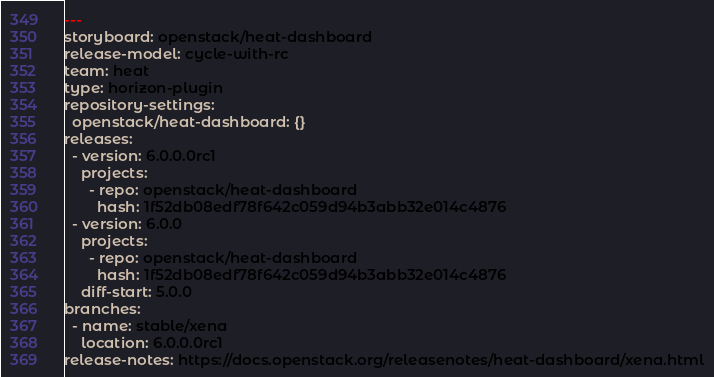Convert code to text. <code><loc_0><loc_0><loc_500><loc_500><_YAML_>---
storyboard: openstack/heat-dashboard
release-model: cycle-with-rc
team: heat
type: horizon-plugin
repository-settings:
  openstack/heat-dashboard: {}
releases:
  - version: 6.0.0.0rc1
    projects:
      - repo: openstack/heat-dashboard
        hash: 1f52db08edf78f642c059d94b3abb32e014c4876
  - version: 6.0.0
    projects:
      - repo: openstack/heat-dashboard
        hash: 1f52db08edf78f642c059d94b3abb32e014c4876
    diff-start: 5.0.0
branches:
  - name: stable/xena
    location: 6.0.0.0rc1
release-notes: https://docs.openstack.org/releasenotes/heat-dashboard/xena.html
</code> 